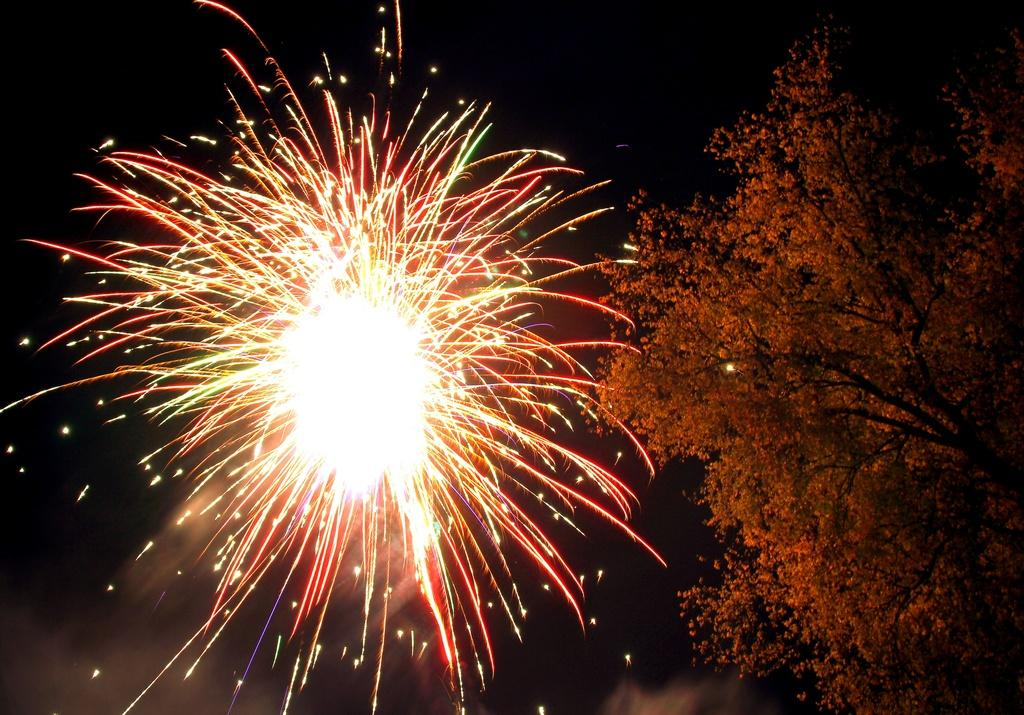What is the main subject of the image? The main subject of the image is fireworks. What can be seen on the right side of the image? There is a tree on the right side of the image. What is the color of the tree? The tree is orange in color. What is the color of the sky in the background of the image? The sky is dark in the background of the image. How do the horses in the image express their feelings about the fireworks? There are no horses present in the image, so it is not possible to answer that question. 